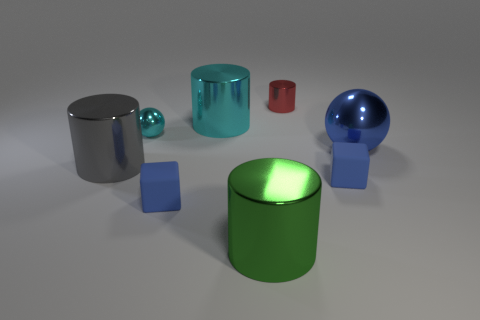Subtract 1 cylinders. How many cylinders are left? 3 Subtract all yellow cylinders. Subtract all yellow blocks. How many cylinders are left? 4 Add 1 big blue balls. How many objects exist? 9 Subtract all cubes. How many objects are left? 6 Add 2 large green metallic things. How many large green metallic things are left? 3 Add 5 big gray things. How many big gray things exist? 6 Subtract 1 red cylinders. How many objects are left? 7 Subtract all big blue spheres. Subtract all large metal spheres. How many objects are left? 6 